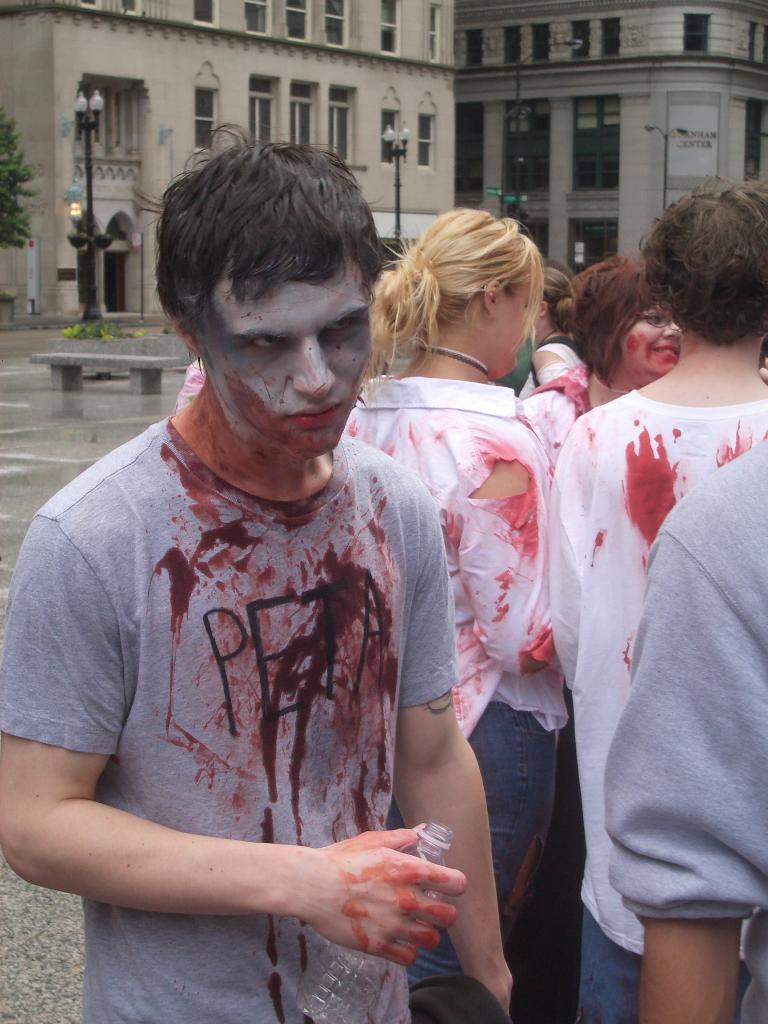How many people are in the image? There are people in the image, but the exact number is not specified. What is the person holding in the image? A person is holding a bottle in the image. What can be seen in the background of the image? There are light poles, buildings, and a tree with green color in the background. What is the purpose of the base in the image? There is no base present in the image, so it is not possible to determine its purpose. 